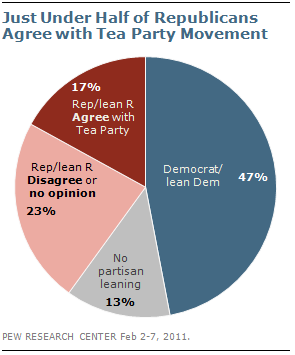Specify some key components in this picture. The political party affiliation of individuals is a significant predictor of whether they agree with the Tea Party movement, with a majority of self-identified Democrats disagreeing with the Tea Party movement, compared to a majority of self-identified Republicans who agree with it. A survey revealed that 47% of Democrats agree with the Tea Party movement. 